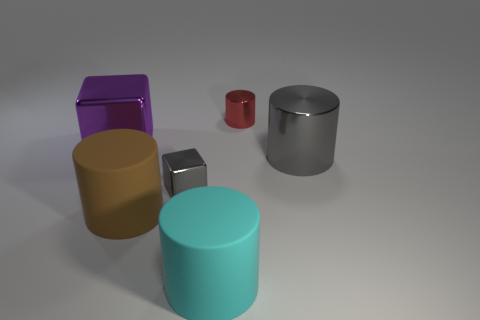How many purple things are in front of the large gray metallic object?
Offer a terse response. 0. There is a large object that is behind the brown matte cylinder and right of the big purple cube; what is it made of?
Provide a succinct answer. Metal. How many cubes are green objects or big objects?
Keep it short and to the point. 1. There is another thing that is the same shape as the tiny gray metal thing; what material is it?
Give a very brief answer. Metal. What is the size of the cyan thing that is the same material as the big brown thing?
Your answer should be compact. Large. There is a rubber thing that is on the right side of the gray metallic cube; does it have the same shape as the gray thing that is on the right side of the small gray object?
Give a very brief answer. Yes. There is a tiny cube that is the same material as the large cube; what is its color?
Your answer should be compact. Gray. Do the block in front of the large gray object and the shiny cylinder that is in front of the large purple object have the same size?
Ensure brevity in your answer.  No. There is a thing that is both on the left side of the tiny red cylinder and right of the small cube; what is its shape?
Your answer should be compact. Cylinder. Are there any yellow blocks made of the same material as the purple object?
Give a very brief answer. No. 